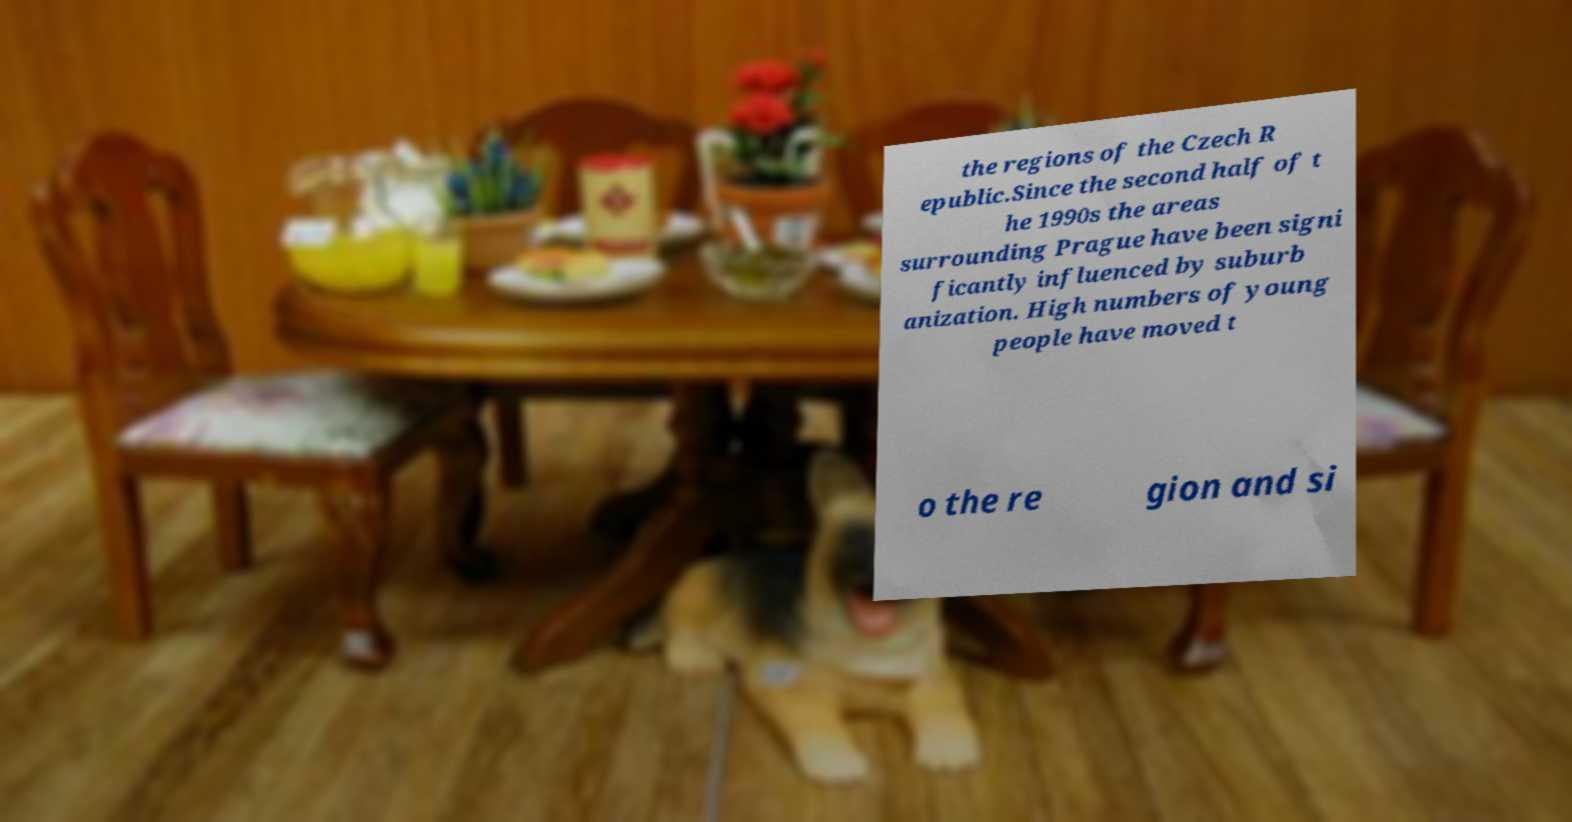Can you accurately transcribe the text from the provided image for me? the regions of the Czech R epublic.Since the second half of t he 1990s the areas surrounding Prague have been signi ficantly influenced by suburb anization. High numbers of young people have moved t o the re gion and si 